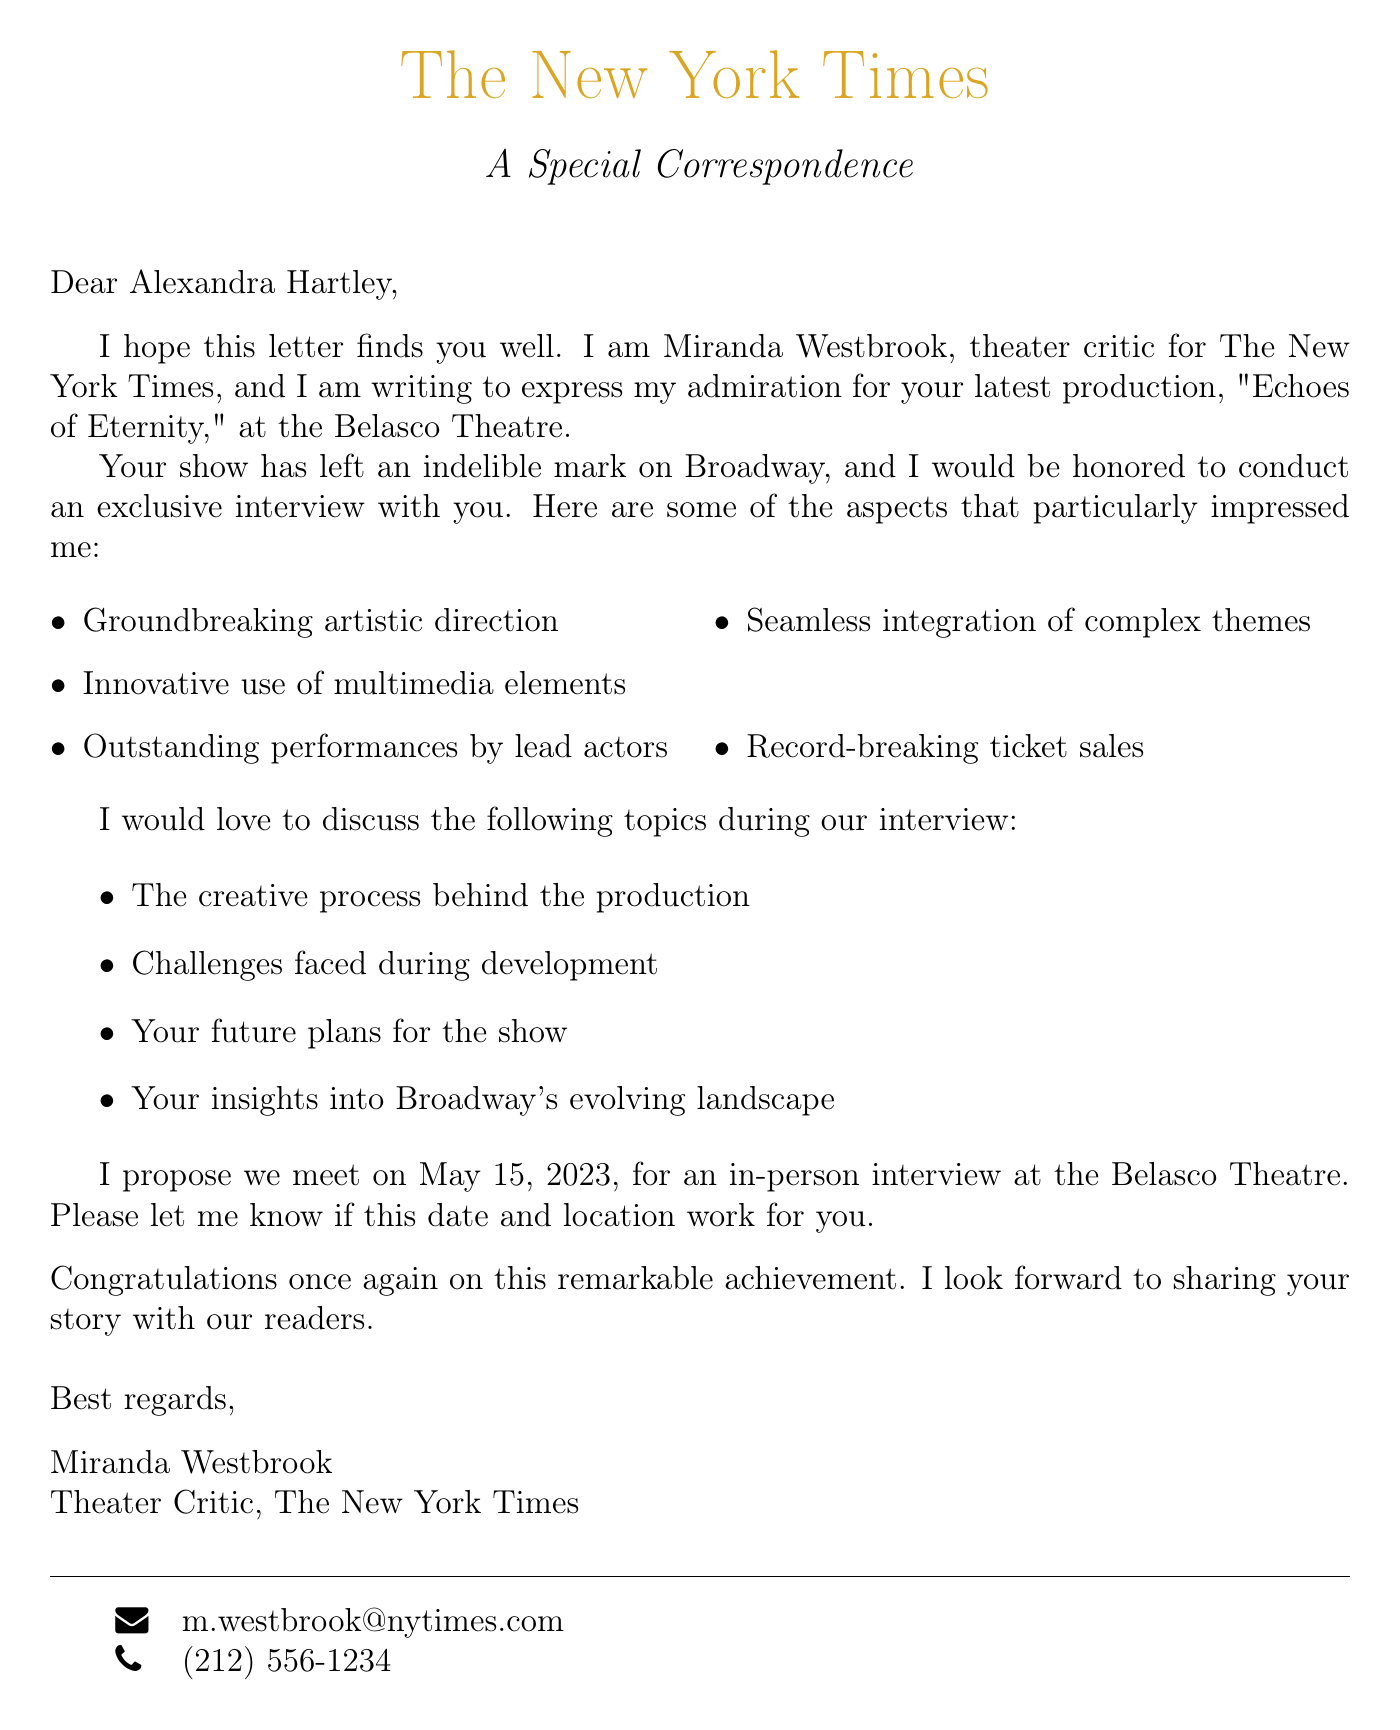What is the name of the theater critic? The letter identifies the critic as Miranda Westbrook.
Answer: Miranda Westbrook What is the title of the production? The production is titled "Echoes of Eternity."
Answer: Echoes of Eternity On what date is the proposed interview? The proposed date for the interview is given in the letter.
Answer: May 15, 2023 Which theater is hosting the production? The theater hosting the production is mentioned in the letter.
Answer: Belasco Theatre What are two of the key points praised in the letter? The letter lists several key points; two examples are groundbreaking artistic direction and record-breaking ticket sales.
Answer: Groundbreaking artistic direction, record-breaking ticket sales What format is the proposed interview? The letter specifies the format of the interview.
Answer: In-person at the Belasco Theatre What is one of the interview topics suggested? The suggested topics for discussion include various aspects of the production; one example is the creative process behind the production.
Answer: The creative process behind the production How does the critic conclude the letter? The closing remarks of the critic are expressed in a positive tone.
Answer: Congratulations on this remarkable achievement What is the email address of the critic? The letter provides contact details for the critic, including the email address.
Answer: m.westbrook@nytimes.com 